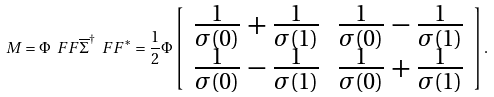<formula> <loc_0><loc_0><loc_500><loc_500>M = \Phi \ F F \overline { \Sigma } ^ { \dagger } \ F F ^ { * } = \frac { 1 } { 2 } \Phi \left [ \begin{array} { r r } \frac { 1 } { \sigma ( 0 ) } + \frac { 1 } { \sigma ( 1 ) } & \frac { 1 } { \sigma ( 0 ) } - \frac { 1 } { \sigma ( 1 ) } \\ \frac { 1 } { \sigma ( 0 ) } - \frac { 1 } { \sigma ( 1 ) } & \frac { 1 } { \sigma ( 0 ) } + \frac { 1 } { \sigma ( 1 ) } \end{array} \right ] .</formula> 